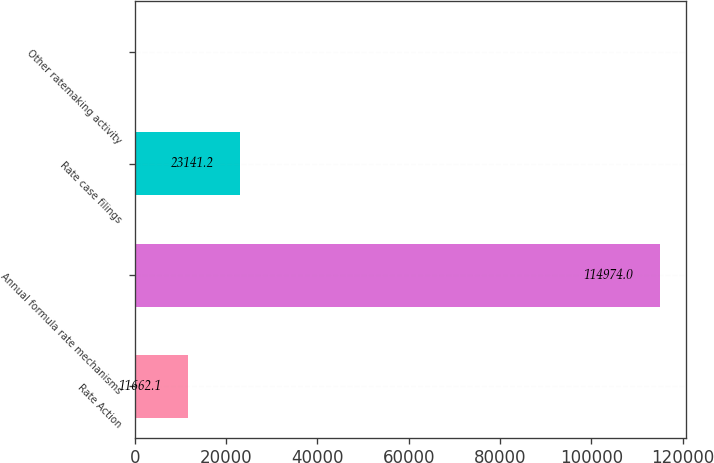Convert chart. <chart><loc_0><loc_0><loc_500><loc_500><bar_chart><fcel>Rate Action<fcel>Annual formula rate mechanisms<fcel>Rate case filings<fcel>Other ratemaking activity<nl><fcel>11662.1<fcel>114974<fcel>23141.2<fcel>183<nl></chart> 